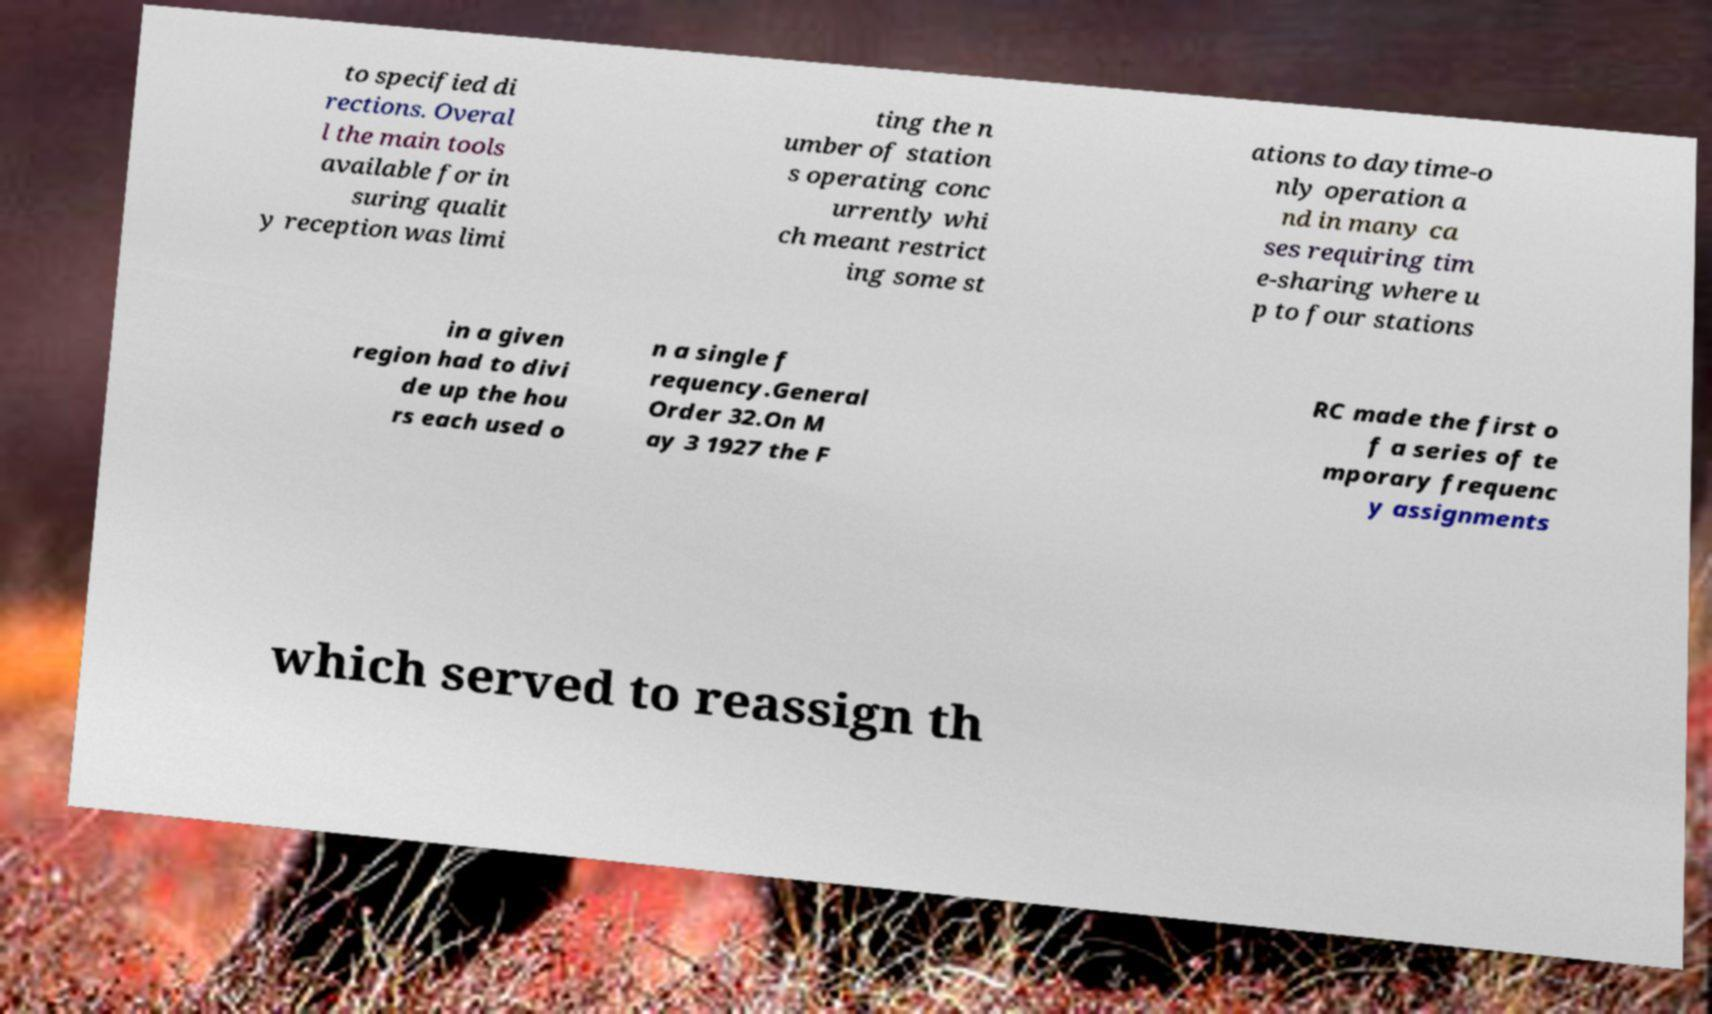I need the written content from this picture converted into text. Can you do that? to specified di rections. Overal l the main tools available for in suring qualit y reception was limi ting the n umber of station s operating conc urrently whi ch meant restrict ing some st ations to daytime-o nly operation a nd in many ca ses requiring tim e-sharing where u p to four stations in a given region had to divi de up the hou rs each used o n a single f requency.General Order 32.On M ay 3 1927 the F RC made the first o f a series of te mporary frequenc y assignments which served to reassign th 